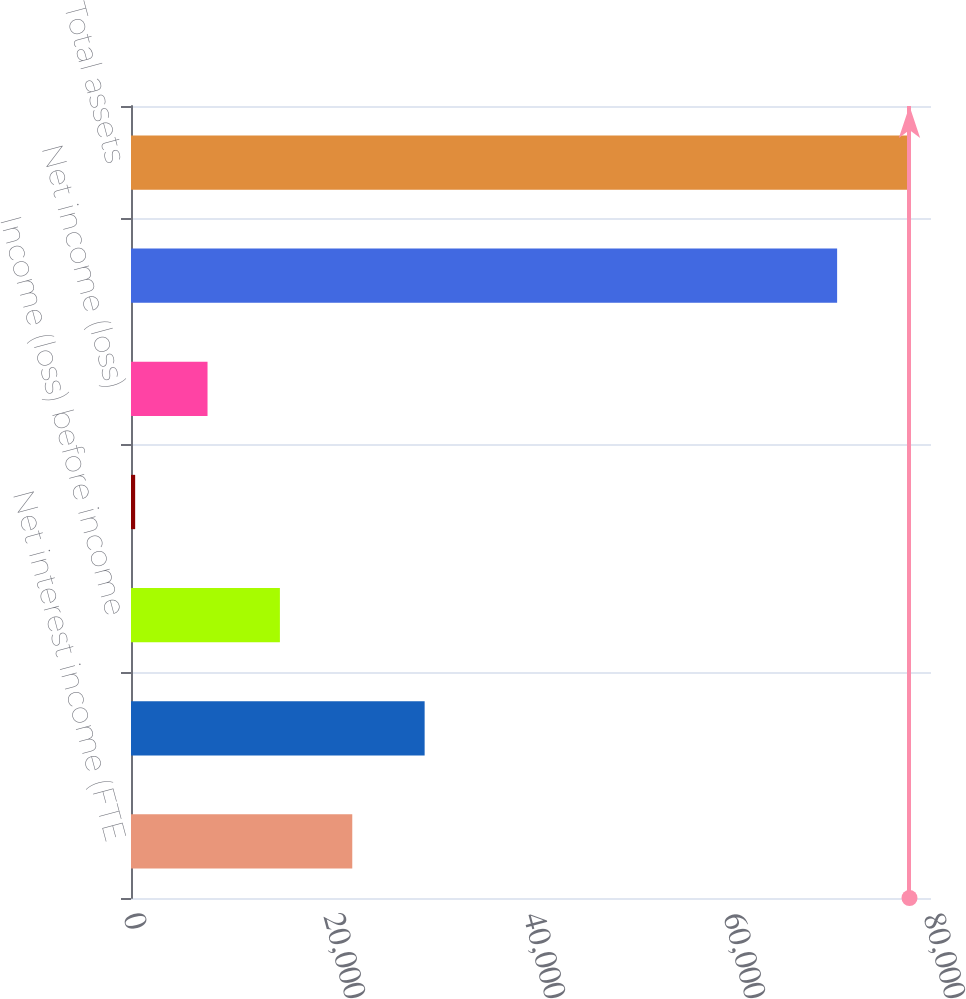Convert chart. <chart><loc_0><loc_0><loc_500><loc_500><bar_chart><fcel>Net interest income (FTE<fcel>All other noninterest expense<fcel>Income (loss) before income<fcel>Income tax expense (benefit)<fcel>Net income (loss)<fcel>Total earning assets<fcel>Total assets<nl><fcel>22126.7<fcel>29363.6<fcel>14889.8<fcel>416<fcel>7652.9<fcel>70612<fcel>77848.9<nl></chart> 